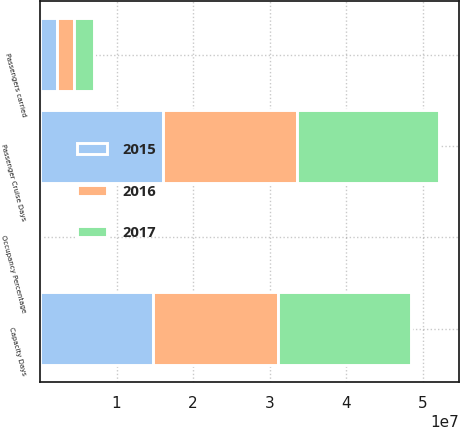Convert chart. <chart><loc_0><loc_0><loc_500><loc_500><stacked_bar_chart><ecel><fcel>Passengers carried<fcel>Passenger Cruise Days<fcel>Capacity Days<fcel>Occupancy Percentage<nl><fcel>2017<fcel>2.51932e+06<fcel>1.8523e+07<fcel>1.73634e+07<fcel>106.7<nl><fcel>2016<fcel>2.33731e+06<fcel>1.75887e+07<fcel>1.63761e+07<fcel>107.4<nl><fcel>2015<fcel>2.1644e+06<fcel>1.60277e+07<fcel>1.4701e+07<fcel>109<nl></chart> 